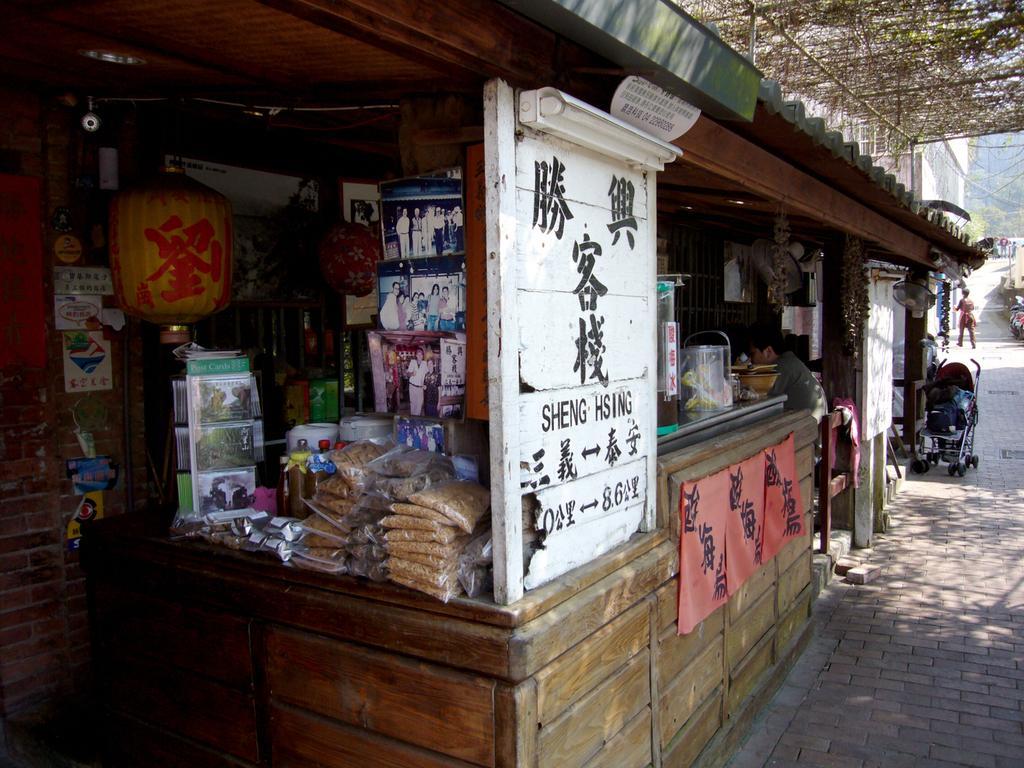How would you summarize this image in a sentence or two? In the center of the image there is a store. There is a person sitting on a chair. At the bottom of the image there is a road. 